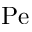<formula> <loc_0><loc_0><loc_500><loc_500>P e</formula> 